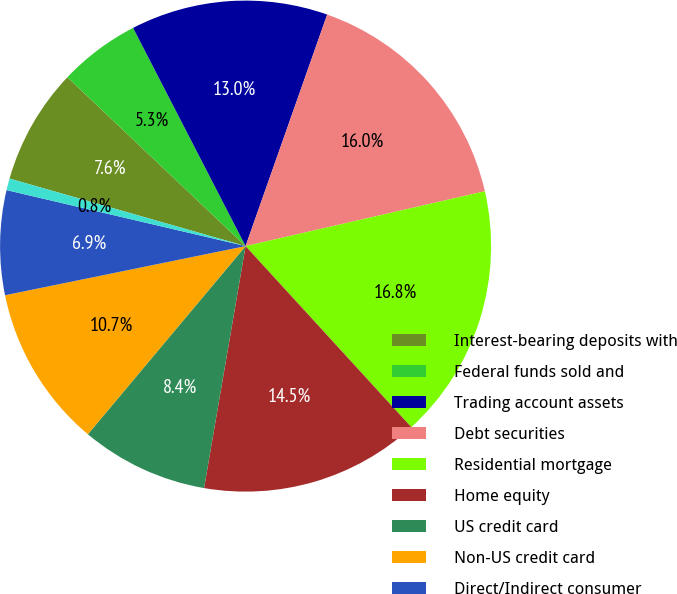Convert chart. <chart><loc_0><loc_0><loc_500><loc_500><pie_chart><fcel>Interest-bearing deposits with<fcel>Federal funds sold and<fcel>Trading account assets<fcel>Debt securities<fcel>Residential mortgage<fcel>Home equity<fcel>US credit card<fcel>Non-US credit card<fcel>Direct/Indirect consumer<fcel>Other consumer<nl><fcel>7.64%<fcel>5.35%<fcel>12.97%<fcel>16.02%<fcel>16.79%<fcel>14.5%<fcel>8.4%<fcel>10.69%<fcel>6.87%<fcel>0.77%<nl></chart> 